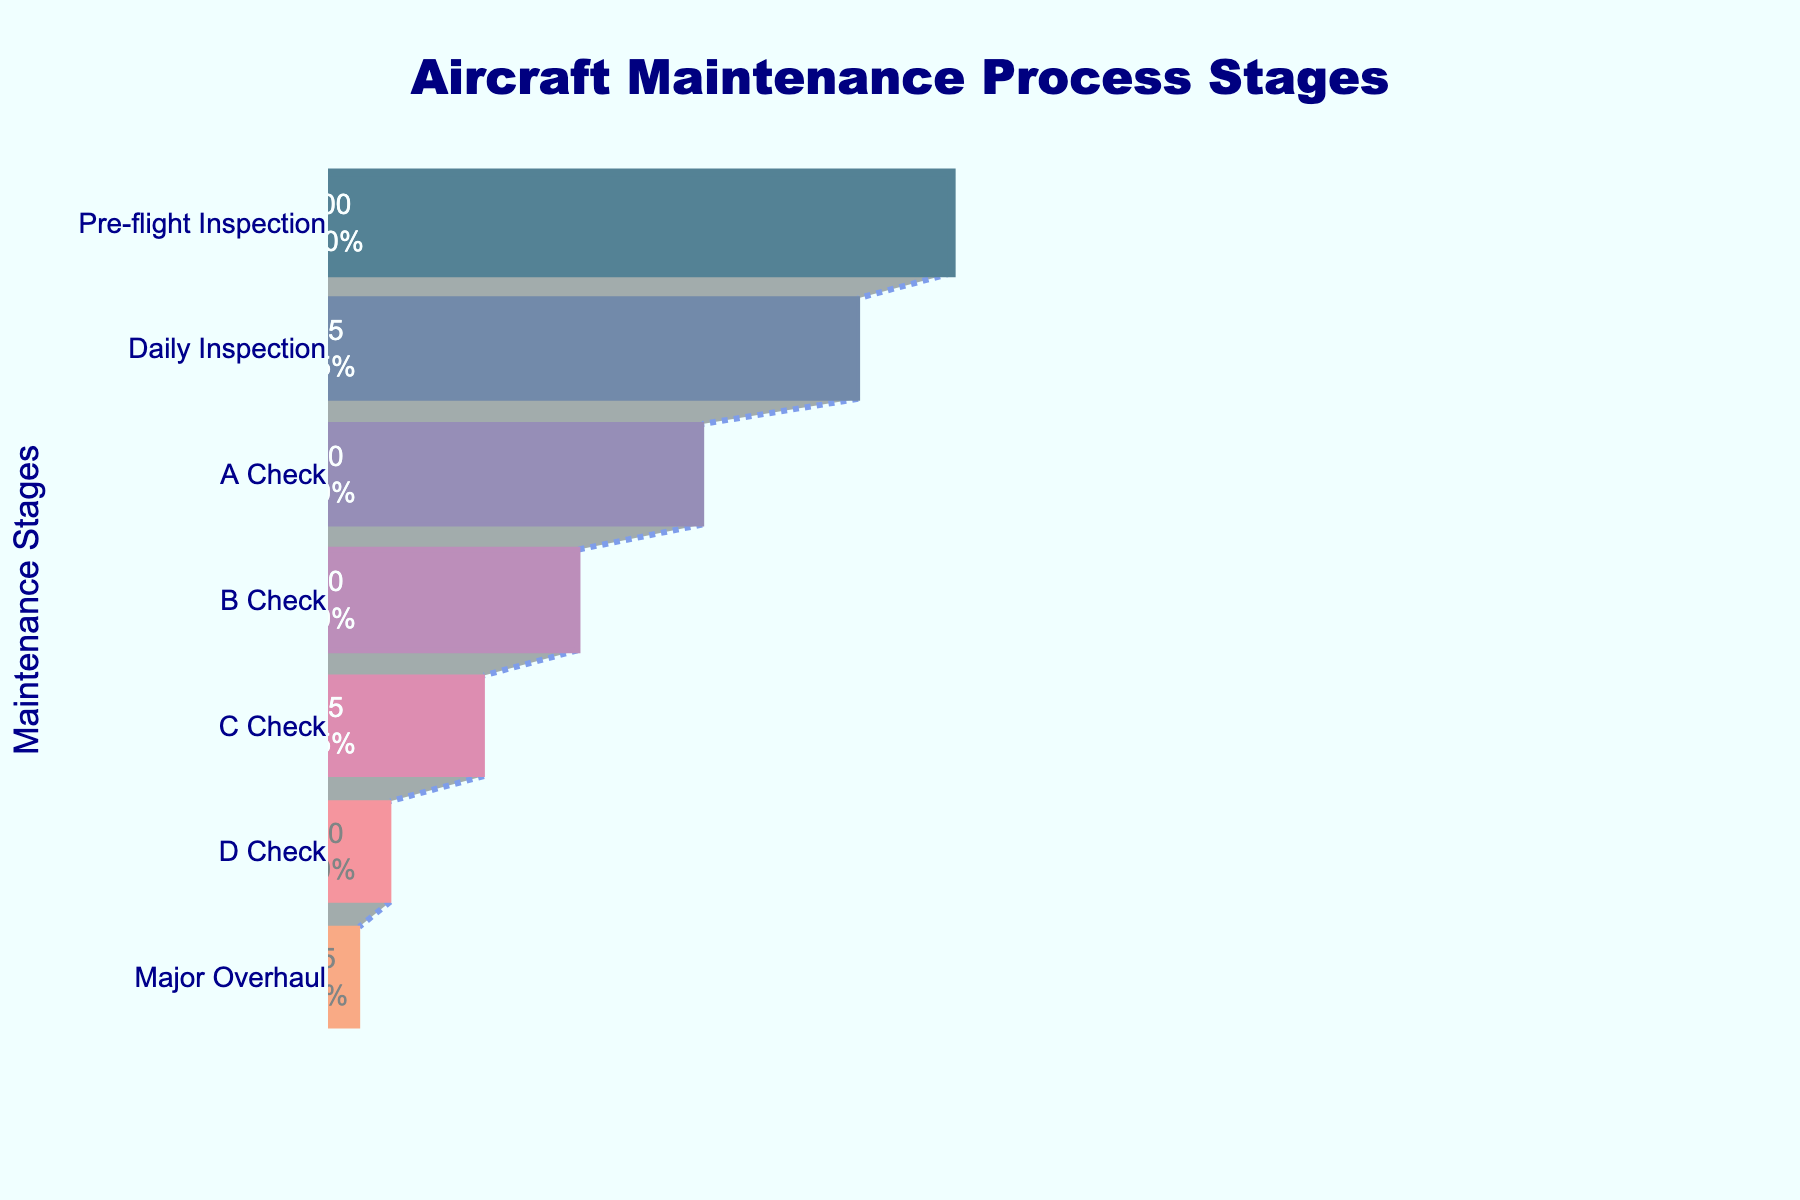What is the title of the funnel chart? The title is located at the top center of the funnel chart, typically in a larger, bold font for emphasis. It reads "Aircraft Maintenance Process Stages".
Answer: Aircraft Maintenance Process Stages Which maintenance stage involves the highest number of aircraft? The stage with the highest number of aircraft will be at the top of the funnel since the funnel illustrates a decreasing sequence. The highest number is represented in the "Pre-flight Inspection" stage.
Answer: Pre-flight Inspection What percentage of aircraft remains after the Daily Inspection stage? To find the percentage, look at the number on the second layer of the funnel, which shows '85'. Then, divide by the initial number of aircraft in the pre-flight stage ‘100’. (85/100 * 100) = 85%.
Answer: 85% How many more aircraft undergo the A Check than the C Check? From the funnel chart, we can see that '60' aircraft undergo the A Check and '25' undergo the C Check. The difference is calculated as 60 - 25.
Answer: 35 What is the percentage loss from B Check to Major Overhaul? We need to find out the number of aircraft after the B Check, which is '40', and the number that remain after Major Overhaul, which is '5'. Then, the percentage loss is computed as ((40 - 5) / 40) * 100%.
Answer: 87.5% Which stage shows the steepest drop in the number of aircraft? To find this, calculate the differences between each consecutive stage and identify the largest drop. Compare all drops: 
- Pre-flight to Daily: 100 - 85 = 15 
- Daily to A Check: 85 - 60 = 25 
- A Check to B Check: 60 - 40 = 20 
- B Check to C Check: 40 - 25 = 15 
- C Check to D Check: 25 - 10 = 15 
- D Check to Major Overhaul: 10 - 5 = 5. 
The steepest drop is from Daily to A Check, which is 25.
Answer: Daily to A Check How many aircraft reduce from C Check to Major Overhaul? From the chart, at the C Check stage, we have 25 aircraft and at the Major Overhaul stage, we have 5. Subtract the two: 25 - 5 = 20.
Answer: 20 What fraction of aircraft complete all stages up to the D Check? Take the number of aircraft in the D Check stage, which is 10, and divide it by the initial number, which is 100: 10/100 = 1/10.
Answer: 1/10 Which stages only have single-digit percentages displayed inside them? Referring to the funnel stages with percentages, those with single digits are in the D Check and Major Overhaul stages.
Answer: D Check and Major Overhaul 